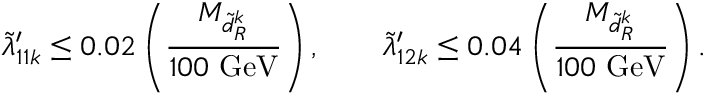<formula> <loc_0><loc_0><loc_500><loc_500>\tilde { \lambda } _ { 1 1 k } ^ { \prime } \leq 0 . 0 2 \left ( \frac { M _ { \tilde { d } _ { R } ^ { k } } } { 1 0 0 G e V } \right ) , \quad \tilde { \lambda } _ { 1 2 k } ^ { \prime } \leq 0 . 0 4 \left ( \frac { M _ { \tilde { d } _ { R } ^ { k } } } { 1 0 0 G e V } \right ) .</formula> 